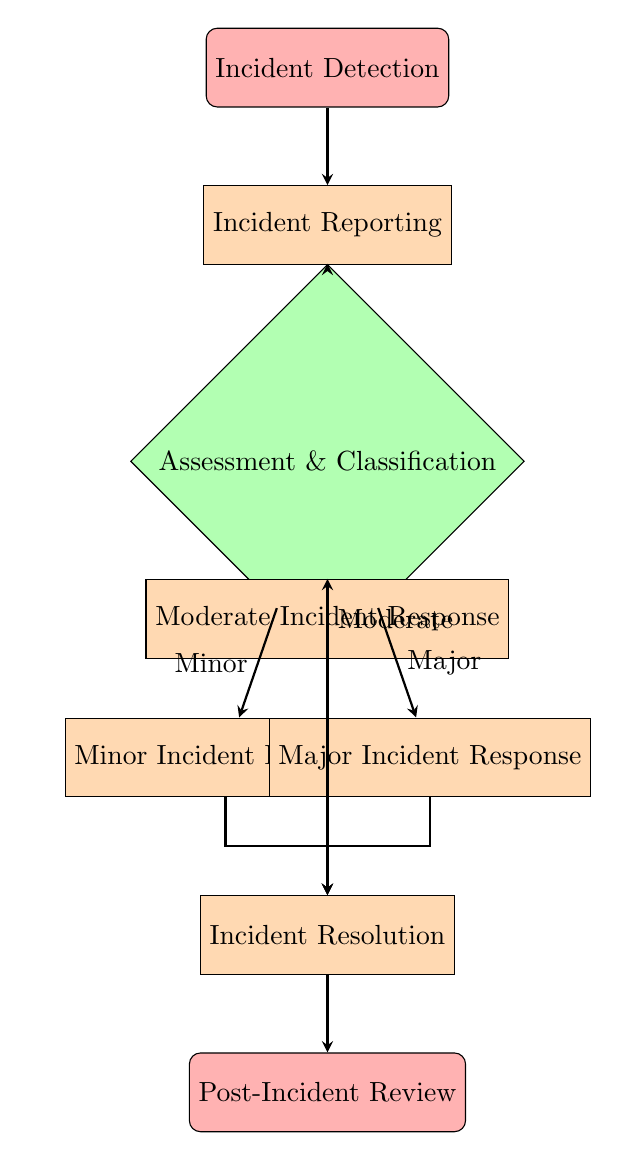What is the starting point of the flow chart? The flow chart begins with the node labeled "Incident Detection." This is the first step in the emergency protocols for logistics operations.
Answer: Incident Detection How many nodes are there in total? By counting all the distinct boxes in the diagram, we find there are eight nodes depicted.
Answer: Eight What happens after "Assessment & Classification"? After "Assessment & Classification," there are three potential responses represented by "Minor Incident Response," "Moderate Incident Response," and "Major Incident Response," depending on the severity of the incident.
Answer: Three responses Which node follows "Major Incident Response"? After "Major Incident Response," the next step is "Incident Resolution." This indicates that regardless of the type of incident, all paths lead to resolving the issue.
Answer: Incident Resolution What type of response is designated for minor incidents? The response for minor incidents is "Minor Incident Response," where the emphasis is on notifying the customer and possibly rescheduling delivery.
Answer: Minor Incident Response How do the paths from "Assessment & Classification" connect to "Incident Resolution"? The paths from "Assessment & Classification" branch out to three different responses and then all indicate a connection to "Incident Resolution," which shows that resolution follows the response irrespective of severity.
Answer: Branch out then connect What step occurs after "Incident Resolution"? The step that follows "Incident Resolution" is the "Post-Incident Review," which involves evaluating the incident and improving future protocols.
Answer: Post-Incident Review What is the description of "Moderate Incident Response"? The description of "Moderate Incident Response" states that it involves mobilizing a recovery team and arranging for alternative transport if necessary.
Answer: Mobilize a recovery team and arrange for alternative transport What does the final step of the protocol focus on? The final step, "Post-Incident Review," focuses on conducting a thorough review of the incident to document lessons learned and improve future protocols.
Answer: Review and improve protocols 